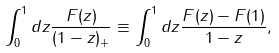Convert formula to latex. <formula><loc_0><loc_0><loc_500><loc_500>\int _ { 0 } ^ { 1 } d z \frac { F ( z ) } { ( 1 - z ) _ { + } } \equiv \int _ { 0 } ^ { 1 } d z \frac { F ( z ) - F ( 1 ) } { 1 - z } ,</formula> 